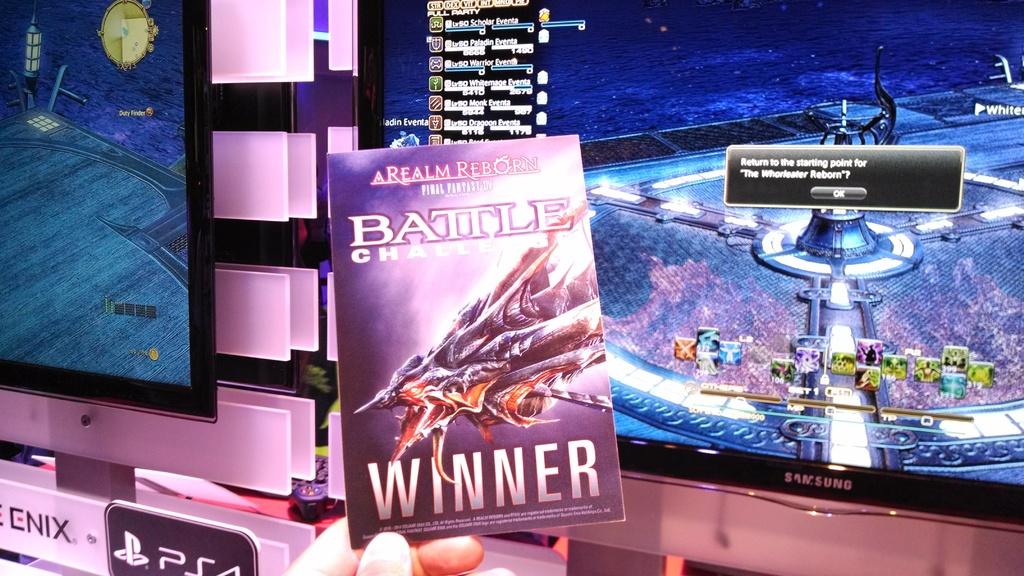What is the game's console name?
Offer a terse response. Ps4. What book is that?
Make the answer very short. Battle challenge. 